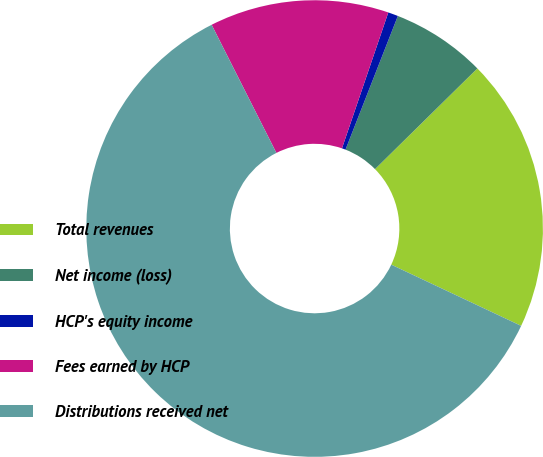Convert chart. <chart><loc_0><loc_0><loc_500><loc_500><pie_chart><fcel>Total revenues<fcel>Net income (loss)<fcel>HCP's equity income<fcel>Fees earned by HCP<fcel>Distributions received net<nl><fcel>19.38%<fcel>6.69%<fcel>0.71%<fcel>12.68%<fcel>60.55%<nl></chart> 